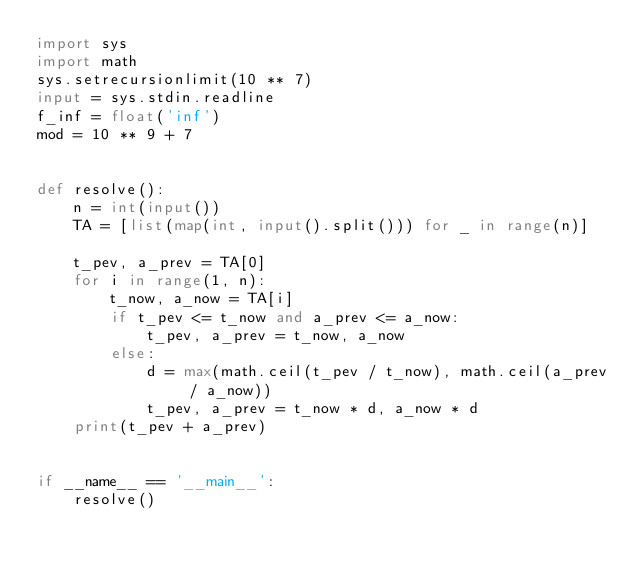<code> <loc_0><loc_0><loc_500><loc_500><_Python_>import sys
import math
sys.setrecursionlimit(10 ** 7)
input = sys.stdin.readline
f_inf = float('inf')
mod = 10 ** 9 + 7


def resolve():
    n = int(input())
    TA = [list(map(int, input().split())) for _ in range(n)]

    t_pev, a_prev = TA[0]
    for i in range(1, n):
        t_now, a_now = TA[i]
        if t_pev <= t_now and a_prev <= a_now:
            t_pev, a_prev = t_now, a_now
        else:
            d = max(math.ceil(t_pev / t_now), math.ceil(a_prev / a_now))
            t_pev, a_prev = t_now * d, a_now * d
    print(t_pev + a_prev)


if __name__ == '__main__':
    resolve()
</code> 